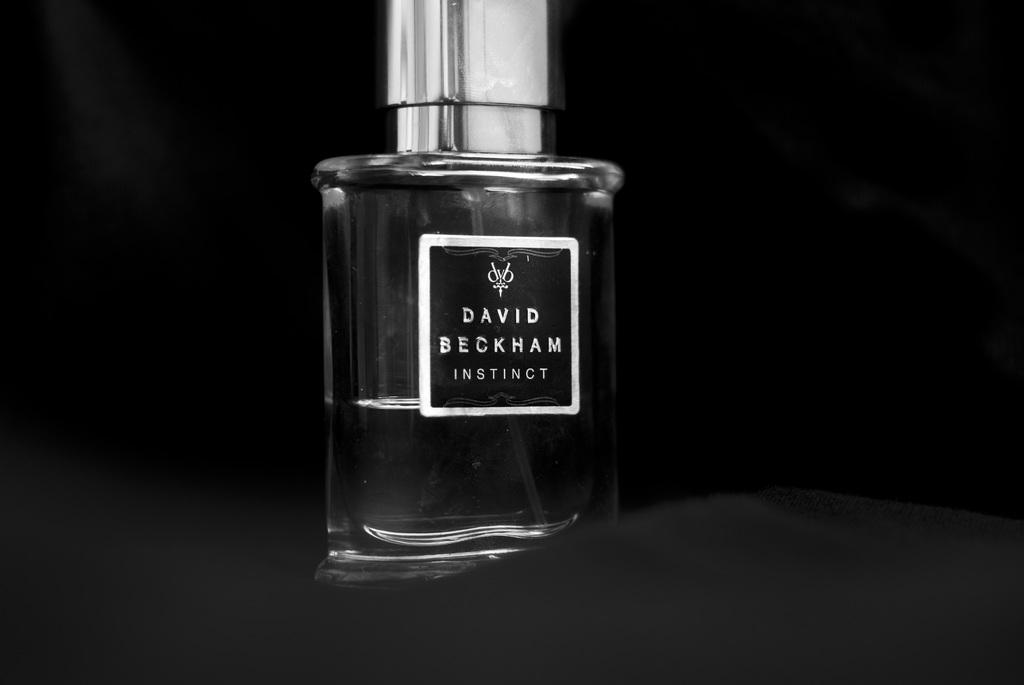<image>
Share a concise interpretation of the image provided. A bottle of David Beckham Instinct Cologne with a black background. 